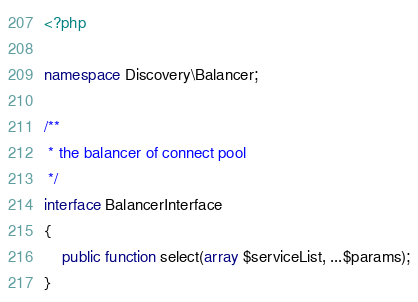<code> <loc_0><loc_0><loc_500><loc_500><_PHP_><?php

namespace Discovery\Balancer;

/**
 * the balancer of connect pool
 */
interface BalancerInterface
{
    public function select(array $serviceList, ...$params);
}
</code> 